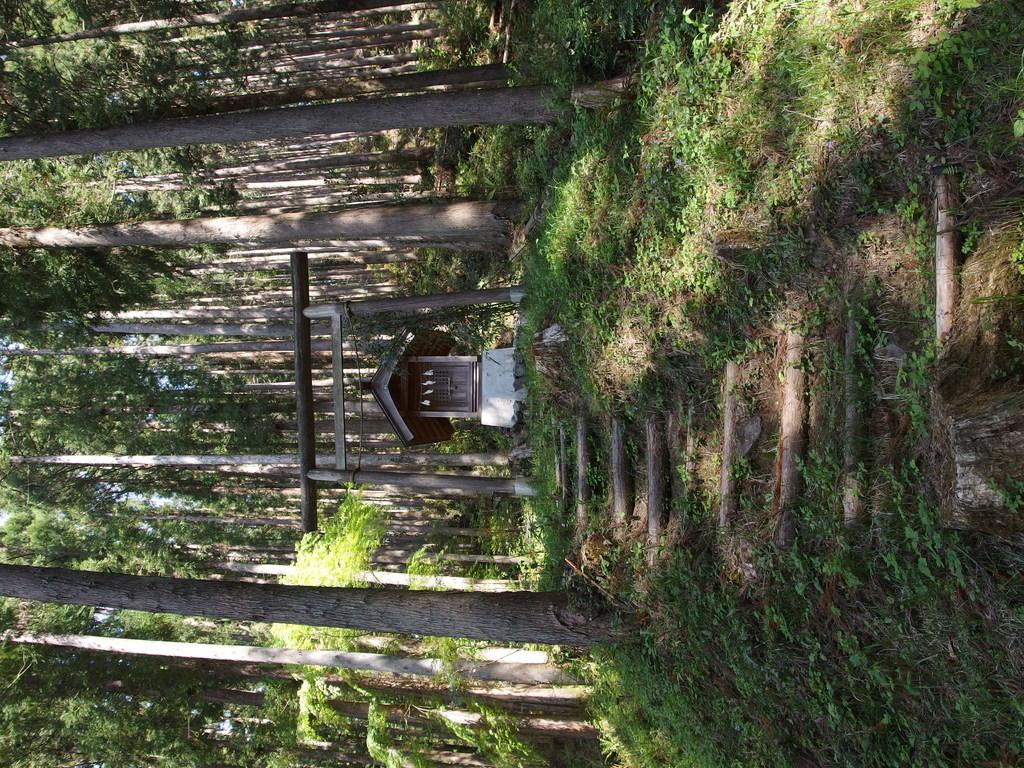What is the main structure in the center of the image? There is a building with a roof in the center of the image. What other objects can be seen in the image? There is a group of wooden poles and a staircase visible in the image. What type of vegetation is visible in the background of the image? There is grass and a group of trees visible in the background of the image. What position does the deer hold in the image? There is no deer present in the image. What material is the lead made of in the image? There is no lead present in the image. 